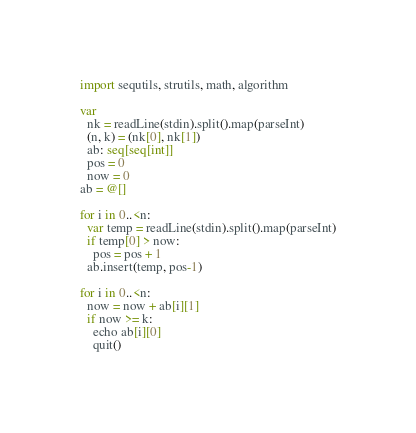Convert code to text. <code><loc_0><loc_0><loc_500><loc_500><_Nim_>import sequtils, strutils, math, algorithm

var
  nk = readLine(stdin).split().map(parseInt)
  (n, k) = (nk[0], nk[1])
  ab: seq[seq[int]]
  pos = 0
  now = 0
ab = @[]

for i in 0..<n:
  var temp = readLine(stdin).split().map(parseInt)
  if temp[0] > now:
    pos = pos + 1
  ab.insert(temp, pos-1)

for i in 0..<n:
  now = now + ab[i][1]
  if now >= k:
    echo ab[i][0]
    quit()</code> 